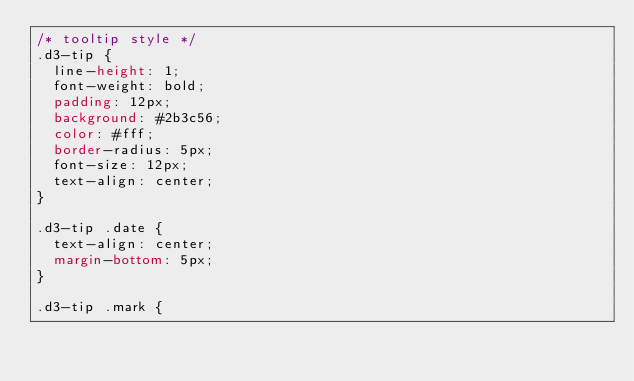<code> <loc_0><loc_0><loc_500><loc_500><_CSS_>/* tooltip style */
.d3-tip {
  line-height: 1;
  font-weight: bold;
  padding: 12px;
  background: #2b3c56;
  color: #fff;
  border-radius: 5px;
  font-size: 12px;
  text-align: center;
}

.d3-tip .date {
  text-align: center;
  margin-bottom: 5px;
}

.d3-tip .mark {</code> 